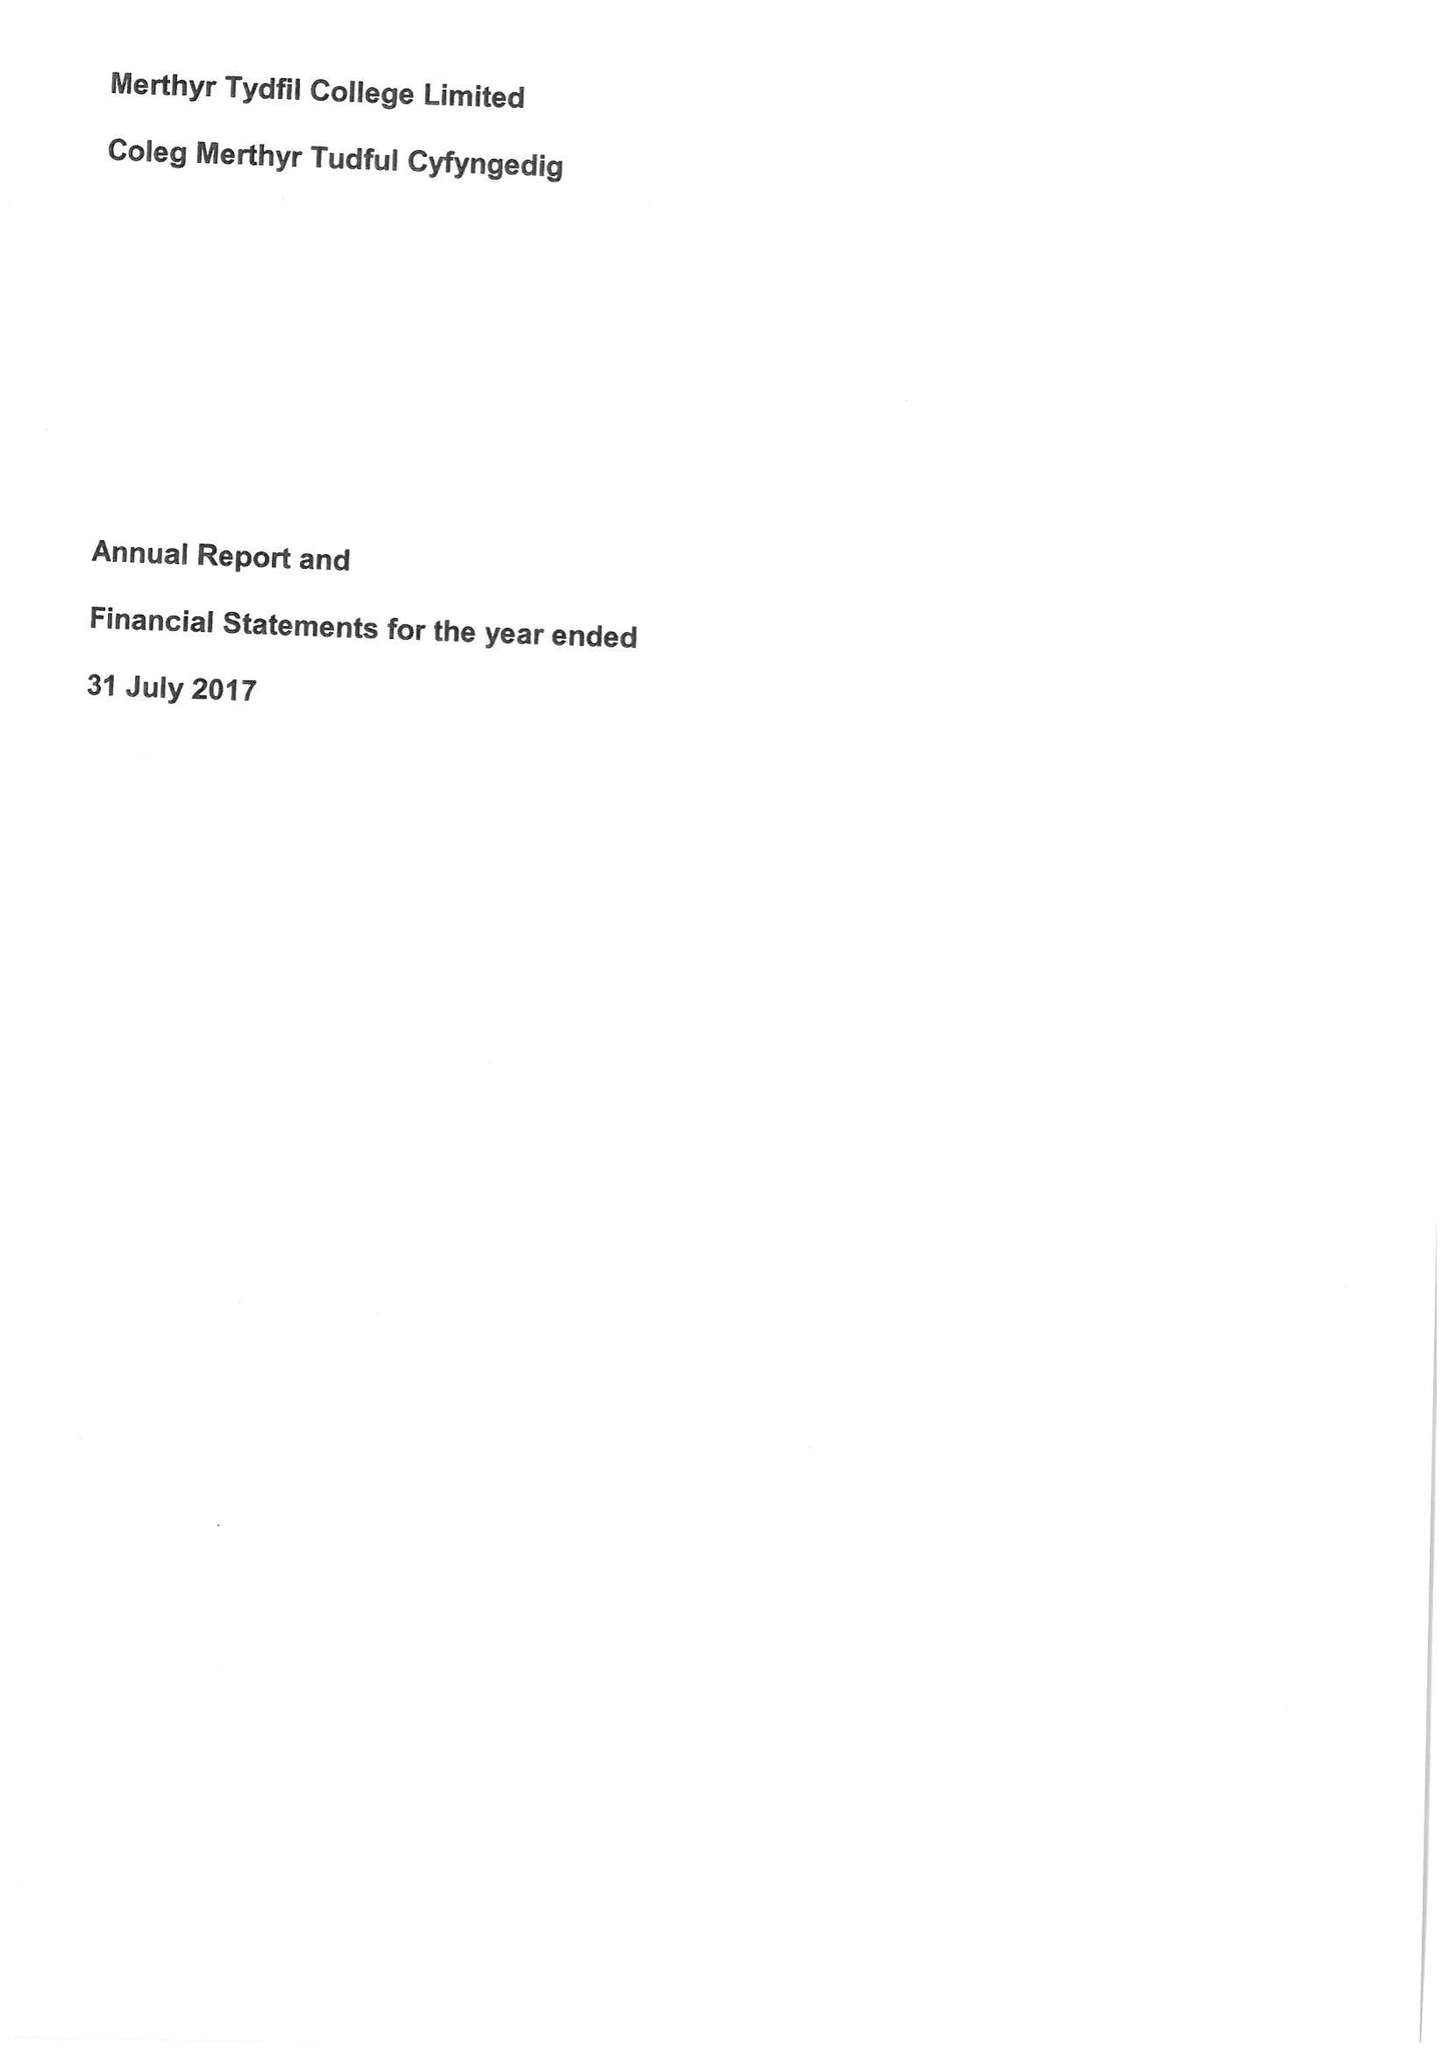What is the value for the address__post_town?
Answer the question using a single word or phrase. PONTYPRIDD 